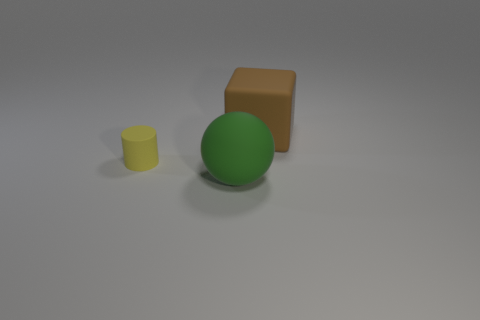There is a big thing that is right of the big matte thing that is on the left side of the matte thing behind the tiny cylinder; what is it made of?
Ensure brevity in your answer.  Rubber. There is a big object that is behind the large thing on the left side of the big block; what is its material?
Your answer should be compact. Rubber. Is the number of brown rubber blocks in front of the cube less than the number of big gray metallic cylinders?
Offer a terse response. No. There is a object on the left side of the big sphere; what is its shape?
Offer a very short reply. Cylinder. There is a brown rubber object; does it have the same size as the matte object that is in front of the tiny yellow rubber object?
Your answer should be compact. Yes. Are there any cylinders made of the same material as the brown thing?
Your answer should be very brief. Yes. How many cylinders are small red shiny objects or brown matte objects?
Keep it short and to the point. 0. There is a object in front of the small cylinder; is there a large brown object that is in front of it?
Offer a terse response. No. Are there fewer gray metallic things than matte blocks?
Your answer should be compact. Yes. How many purple things are either big cubes or matte balls?
Offer a very short reply. 0. 